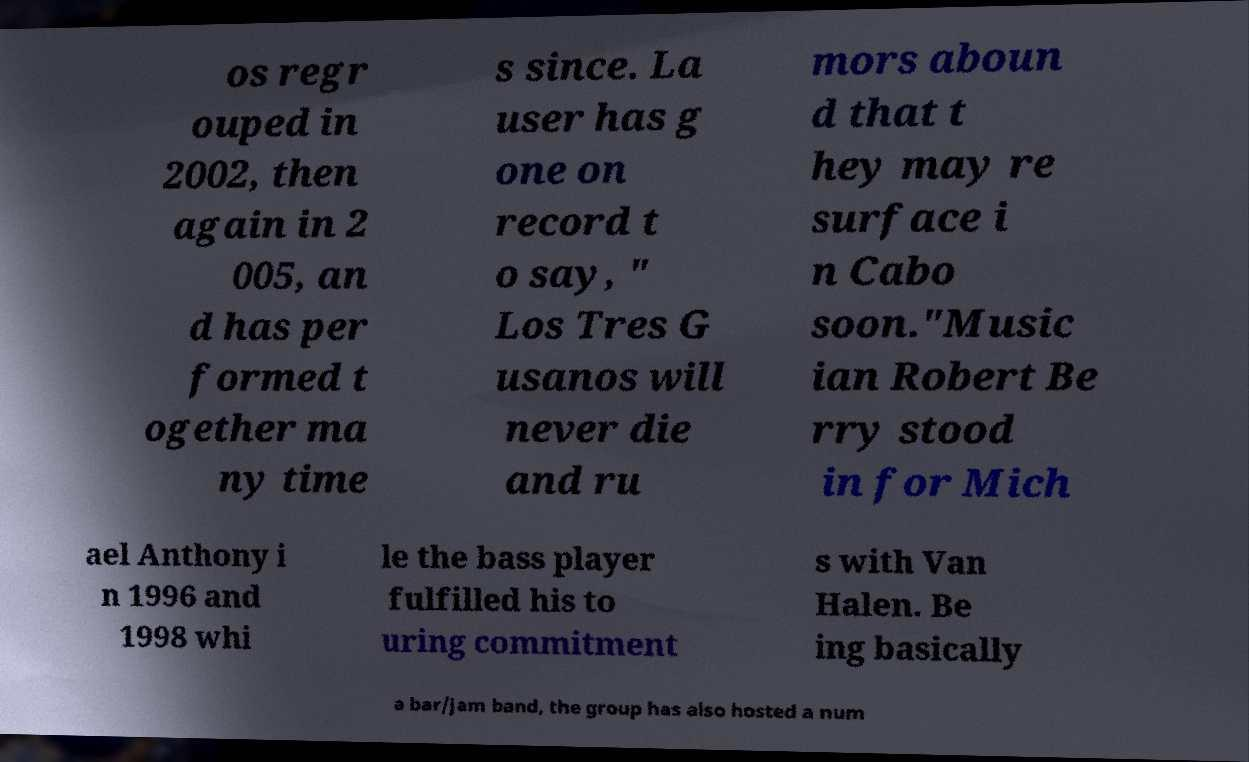Can you accurately transcribe the text from the provided image for me? os regr ouped in 2002, then again in 2 005, an d has per formed t ogether ma ny time s since. La user has g one on record t o say, " Los Tres G usanos will never die and ru mors aboun d that t hey may re surface i n Cabo soon."Music ian Robert Be rry stood in for Mich ael Anthony i n 1996 and 1998 whi le the bass player fulfilled his to uring commitment s with Van Halen. Be ing basically a bar/jam band, the group has also hosted a num 